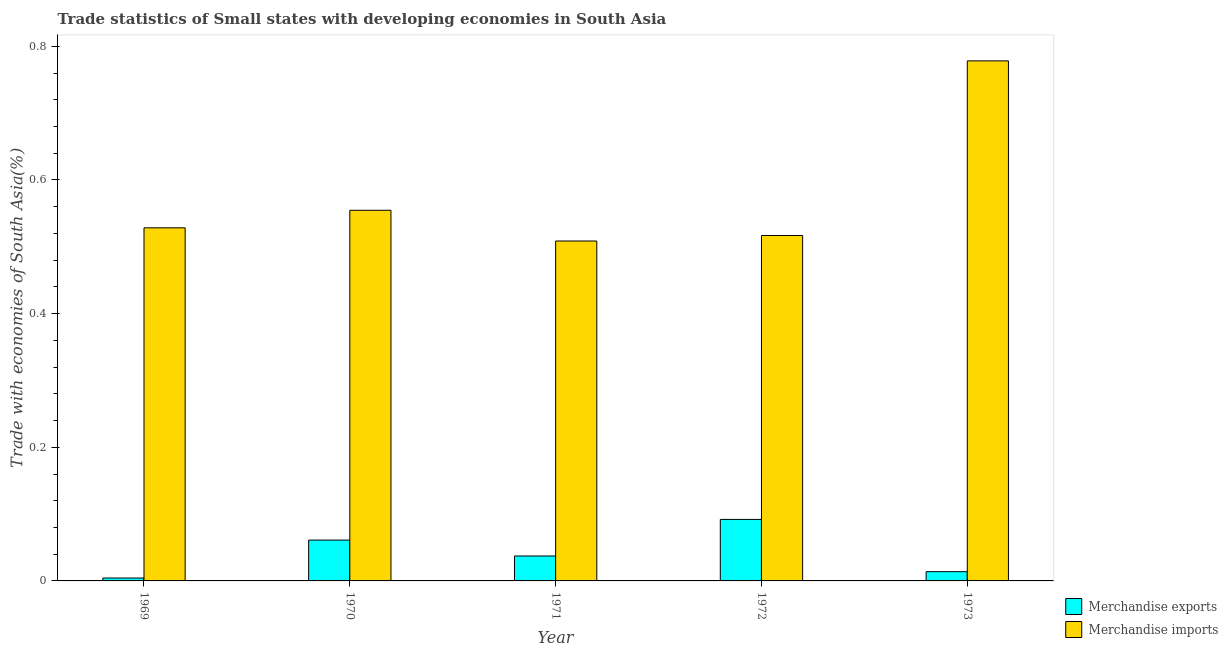How many groups of bars are there?
Your response must be concise. 5. What is the label of the 3rd group of bars from the left?
Keep it short and to the point. 1971. What is the merchandise exports in 1970?
Your answer should be very brief. 0.06. Across all years, what is the maximum merchandise exports?
Provide a succinct answer. 0.09. Across all years, what is the minimum merchandise exports?
Offer a terse response. 0. In which year was the merchandise imports maximum?
Give a very brief answer. 1973. In which year was the merchandise imports minimum?
Provide a short and direct response. 1971. What is the total merchandise imports in the graph?
Make the answer very short. 2.89. What is the difference between the merchandise imports in 1970 and that in 1972?
Ensure brevity in your answer.  0.04. What is the difference between the merchandise imports in 1970 and the merchandise exports in 1973?
Keep it short and to the point. -0.22. What is the average merchandise exports per year?
Give a very brief answer. 0.04. In the year 1970, what is the difference between the merchandise exports and merchandise imports?
Make the answer very short. 0. In how many years, is the merchandise imports greater than 0.32 %?
Keep it short and to the point. 5. What is the ratio of the merchandise exports in 1971 to that in 1973?
Offer a very short reply. 2.69. What is the difference between the highest and the second highest merchandise imports?
Ensure brevity in your answer.  0.22. What is the difference between the highest and the lowest merchandise imports?
Your answer should be very brief. 0.27. In how many years, is the merchandise imports greater than the average merchandise imports taken over all years?
Provide a short and direct response. 1. Is the sum of the merchandise exports in 1969 and 1971 greater than the maximum merchandise imports across all years?
Your response must be concise. No. What does the 1st bar from the right in 1971 represents?
Provide a succinct answer. Merchandise imports. How many bars are there?
Your answer should be compact. 10. How many years are there in the graph?
Provide a short and direct response. 5. What is the difference between two consecutive major ticks on the Y-axis?
Your answer should be very brief. 0.2. Are the values on the major ticks of Y-axis written in scientific E-notation?
Make the answer very short. No. Does the graph contain grids?
Your response must be concise. No. Where does the legend appear in the graph?
Your answer should be very brief. Bottom right. What is the title of the graph?
Make the answer very short. Trade statistics of Small states with developing economies in South Asia. What is the label or title of the Y-axis?
Ensure brevity in your answer.  Trade with economies of South Asia(%). What is the Trade with economies of South Asia(%) of Merchandise exports in 1969?
Keep it short and to the point. 0. What is the Trade with economies of South Asia(%) of Merchandise imports in 1969?
Your response must be concise. 0.53. What is the Trade with economies of South Asia(%) of Merchandise exports in 1970?
Ensure brevity in your answer.  0.06. What is the Trade with economies of South Asia(%) in Merchandise imports in 1970?
Provide a short and direct response. 0.55. What is the Trade with economies of South Asia(%) of Merchandise exports in 1971?
Give a very brief answer. 0.04. What is the Trade with economies of South Asia(%) of Merchandise imports in 1971?
Give a very brief answer. 0.51. What is the Trade with economies of South Asia(%) in Merchandise exports in 1972?
Offer a terse response. 0.09. What is the Trade with economies of South Asia(%) in Merchandise imports in 1972?
Give a very brief answer. 0.52. What is the Trade with economies of South Asia(%) in Merchandise exports in 1973?
Give a very brief answer. 0.01. What is the Trade with economies of South Asia(%) in Merchandise imports in 1973?
Your answer should be compact. 0.78. Across all years, what is the maximum Trade with economies of South Asia(%) of Merchandise exports?
Your answer should be compact. 0.09. Across all years, what is the maximum Trade with economies of South Asia(%) of Merchandise imports?
Offer a very short reply. 0.78. Across all years, what is the minimum Trade with economies of South Asia(%) of Merchandise exports?
Offer a very short reply. 0. Across all years, what is the minimum Trade with economies of South Asia(%) of Merchandise imports?
Offer a terse response. 0.51. What is the total Trade with economies of South Asia(%) in Merchandise exports in the graph?
Ensure brevity in your answer.  0.21. What is the total Trade with economies of South Asia(%) of Merchandise imports in the graph?
Keep it short and to the point. 2.89. What is the difference between the Trade with economies of South Asia(%) in Merchandise exports in 1969 and that in 1970?
Your response must be concise. -0.06. What is the difference between the Trade with economies of South Asia(%) in Merchandise imports in 1969 and that in 1970?
Provide a short and direct response. -0.03. What is the difference between the Trade with economies of South Asia(%) in Merchandise exports in 1969 and that in 1971?
Your response must be concise. -0.03. What is the difference between the Trade with economies of South Asia(%) of Merchandise imports in 1969 and that in 1971?
Make the answer very short. 0.02. What is the difference between the Trade with economies of South Asia(%) of Merchandise exports in 1969 and that in 1972?
Provide a short and direct response. -0.09. What is the difference between the Trade with economies of South Asia(%) of Merchandise imports in 1969 and that in 1972?
Make the answer very short. 0.01. What is the difference between the Trade with economies of South Asia(%) of Merchandise exports in 1969 and that in 1973?
Provide a succinct answer. -0.01. What is the difference between the Trade with economies of South Asia(%) in Merchandise imports in 1969 and that in 1973?
Keep it short and to the point. -0.25. What is the difference between the Trade with economies of South Asia(%) of Merchandise exports in 1970 and that in 1971?
Your answer should be compact. 0.02. What is the difference between the Trade with economies of South Asia(%) in Merchandise imports in 1970 and that in 1971?
Keep it short and to the point. 0.05. What is the difference between the Trade with economies of South Asia(%) of Merchandise exports in 1970 and that in 1972?
Provide a succinct answer. -0.03. What is the difference between the Trade with economies of South Asia(%) of Merchandise imports in 1970 and that in 1972?
Your response must be concise. 0.04. What is the difference between the Trade with economies of South Asia(%) of Merchandise exports in 1970 and that in 1973?
Provide a short and direct response. 0.05. What is the difference between the Trade with economies of South Asia(%) in Merchandise imports in 1970 and that in 1973?
Ensure brevity in your answer.  -0.22. What is the difference between the Trade with economies of South Asia(%) of Merchandise exports in 1971 and that in 1972?
Provide a succinct answer. -0.05. What is the difference between the Trade with economies of South Asia(%) in Merchandise imports in 1971 and that in 1972?
Your response must be concise. -0.01. What is the difference between the Trade with economies of South Asia(%) of Merchandise exports in 1971 and that in 1973?
Ensure brevity in your answer.  0.02. What is the difference between the Trade with economies of South Asia(%) of Merchandise imports in 1971 and that in 1973?
Offer a very short reply. -0.27. What is the difference between the Trade with economies of South Asia(%) in Merchandise exports in 1972 and that in 1973?
Your answer should be compact. 0.08. What is the difference between the Trade with economies of South Asia(%) of Merchandise imports in 1972 and that in 1973?
Give a very brief answer. -0.26. What is the difference between the Trade with economies of South Asia(%) in Merchandise exports in 1969 and the Trade with economies of South Asia(%) in Merchandise imports in 1970?
Provide a succinct answer. -0.55. What is the difference between the Trade with economies of South Asia(%) in Merchandise exports in 1969 and the Trade with economies of South Asia(%) in Merchandise imports in 1971?
Keep it short and to the point. -0.5. What is the difference between the Trade with economies of South Asia(%) in Merchandise exports in 1969 and the Trade with economies of South Asia(%) in Merchandise imports in 1972?
Keep it short and to the point. -0.51. What is the difference between the Trade with economies of South Asia(%) in Merchandise exports in 1969 and the Trade with economies of South Asia(%) in Merchandise imports in 1973?
Your answer should be very brief. -0.77. What is the difference between the Trade with economies of South Asia(%) in Merchandise exports in 1970 and the Trade with economies of South Asia(%) in Merchandise imports in 1971?
Give a very brief answer. -0.45. What is the difference between the Trade with economies of South Asia(%) of Merchandise exports in 1970 and the Trade with economies of South Asia(%) of Merchandise imports in 1972?
Keep it short and to the point. -0.46. What is the difference between the Trade with economies of South Asia(%) of Merchandise exports in 1970 and the Trade with economies of South Asia(%) of Merchandise imports in 1973?
Make the answer very short. -0.72. What is the difference between the Trade with economies of South Asia(%) in Merchandise exports in 1971 and the Trade with economies of South Asia(%) in Merchandise imports in 1972?
Ensure brevity in your answer.  -0.48. What is the difference between the Trade with economies of South Asia(%) of Merchandise exports in 1971 and the Trade with economies of South Asia(%) of Merchandise imports in 1973?
Offer a very short reply. -0.74. What is the difference between the Trade with economies of South Asia(%) of Merchandise exports in 1972 and the Trade with economies of South Asia(%) of Merchandise imports in 1973?
Give a very brief answer. -0.69. What is the average Trade with economies of South Asia(%) of Merchandise exports per year?
Your answer should be compact. 0.04. What is the average Trade with economies of South Asia(%) of Merchandise imports per year?
Offer a terse response. 0.58. In the year 1969, what is the difference between the Trade with economies of South Asia(%) in Merchandise exports and Trade with economies of South Asia(%) in Merchandise imports?
Offer a terse response. -0.52. In the year 1970, what is the difference between the Trade with economies of South Asia(%) of Merchandise exports and Trade with economies of South Asia(%) of Merchandise imports?
Keep it short and to the point. -0.49. In the year 1971, what is the difference between the Trade with economies of South Asia(%) of Merchandise exports and Trade with economies of South Asia(%) of Merchandise imports?
Provide a short and direct response. -0.47. In the year 1972, what is the difference between the Trade with economies of South Asia(%) in Merchandise exports and Trade with economies of South Asia(%) in Merchandise imports?
Offer a terse response. -0.42. In the year 1973, what is the difference between the Trade with economies of South Asia(%) in Merchandise exports and Trade with economies of South Asia(%) in Merchandise imports?
Give a very brief answer. -0.76. What is the ratio of the Trade with economies of South Asia(%) of Merchandise exports in 1969 to that in 1970?
Ensure brevity in your answer.  0.07. What is the ratio of the Trade with economies of South Asia(%) in Merchandise imports in 1969 to that in 1970?
Your answer should be very brief. 0.95. What is the ratio of the Trade with economies of South Asia(%) of Merchandise exports in 1969 to that in 1971?
Provide a short and direct response. 0.12. What is the ratio of the Trade with economies of South Asia(%) of Merchandise imports in 1969 to that in 1971?
Offer a very short reply. 1.04. What is the ratio of the Trade with economies of South Asia(%) in Merchandise exports in 1969 to that in 1972?
Make the answer very short. 0.05. What is the ratio of the Trade with economies of South Asia(%) of Merchandise imports in 1969 to that in 1972?
Your answer should be compact. 1.02. What is the ratio of the Trade with economies of South Asia(%) of Merchandise exports in 1969 to that in 1973?
Ensure brevity in your answer.  0.31. What is the ratio of the Trade with economies of South Asia(%) in Merchandise imports in 1969 to that in 1973?
Offer a very short reply. 0.68. What is the ratio of the Trade with economies of South Asia(%) of Merchandise exports in 1970 to that in 1971?
Keep it short and to the point. 1.64. What is the ratio of the Trade with economies of South Asia(%) of Merchandise imports in 1970 to that in 1971?
Offer a terse response. 1.09. What is the ratio of the Trade with economies of South Asia(%) of Merchandise exports in 1970 to that in 1972?
Provide a short and direct response. 0.66. What is the ratio of the Trade with economies of South Asia(%) in Merchandise imports in 1970 to that in 1972?
Your answer should be very brief. 1.07. What is the ratio of the Trade with economies of South Asia(%) of Merchandise exports in 1970 to that in 1973?
Provide a short and direct response. 4.41. What is the ratio of the Trade with economies of South Asia(%) in Merchandise imports in 1970 to that in 1973?
Your response must be concise. 0.71. What is the ratio of the Trade with economies of South Asia(%) in Merchandise exports in 1971 to that in 1972?
Your response must be concise. 0.41. What is the ratio of the Trade with economies of South Asia(%) in Merchandise imports in 1971 to that in 1972?
Your answer should be compact. 0.98. What is the ratio of the Trade with economies of South Asia(%) in Merchandise exports in 1971 to that in 1973?
Offer a terse response. 2.69. What is the ratio of the Trade with economies of South Asia(%) in Merchandise imports in 1971 to that in 1973?
Ensure brevity in your answer.  0.65. What is the ratio of the Trade with economies of South Asia(%) of Merchandise exports in 1972 to that in 1973?
Offer a terse response. 6.64. What is the ratio of the Trade with economies of South Asia(%) of Merchandise imports in 1972 to that in 1973?
Make the answer very short. 0.66. What is the difference between the highest and the second highest Trade with economies of South Asia(%) in Merchandise exports?
Offer a terse response. 0.03. What is the difference between the highest and the second highest Trade with economies of South Asia(%) of Merchandise imports?
Give a very brief answer. 0.22. What is the difference between the highest and the lowest Trade with economies of South Asia(%) in Merchandise exports?
Give a very brief answer. 0.09. What is the difference between the highest and the lowest Trade with economies of South Asia(%) in Merchandise imports?
Keep it short and to the point. 0.27. 